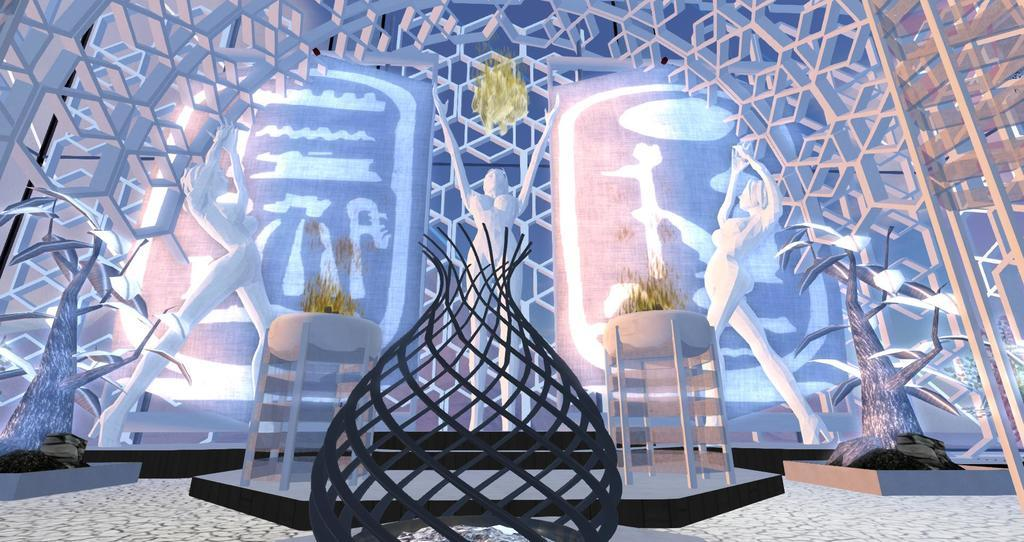What is the main subject of the image? The main subject of the image is an architecture. Are there any additional elements present on the architecture? Yes, there are three human statues on the surface of the architecture. What type of government is depicted in the image? There is no depiction of a government in the image; it features an architecture with human statues. How many spiders can be seen crawling on the architecture in the image? There are no spiders present in the image; it features an architecture with human statues. 